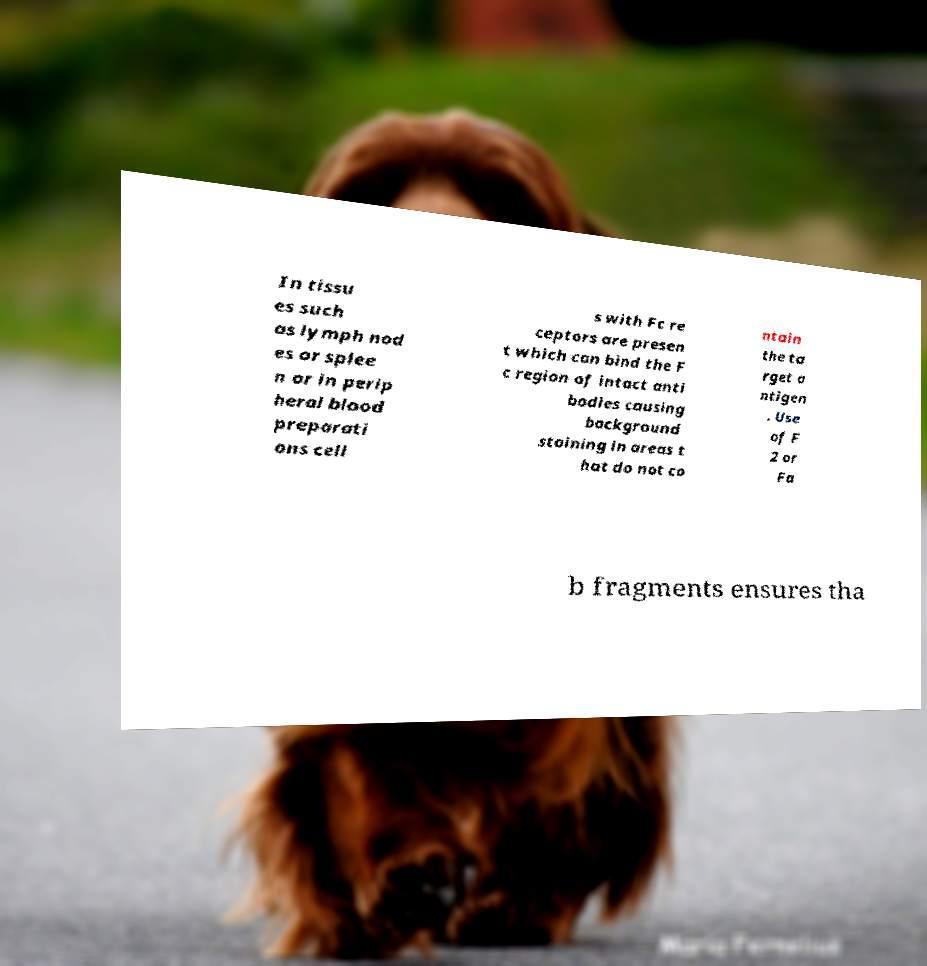Please identify and transcribe the text found in this image. In tissu es such as lymph nod es or splee n or in perip heral blood preparati ons cell s with Fc re ceptors are presen t which can bind the F c region of intact anti bodies causing background staining in areas t hat do not co ntain the ta rget a ntigen . Use of F 2 or Fa b fragments ensures tha 